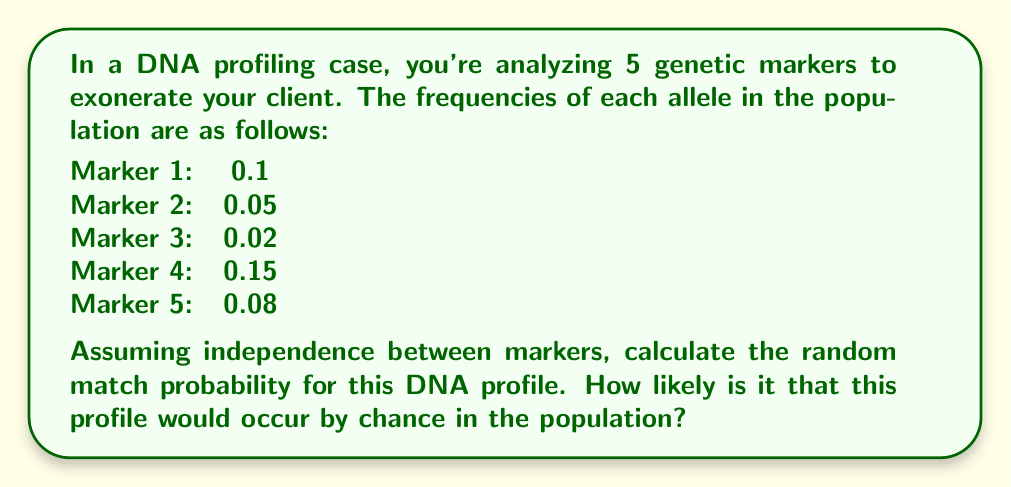Show me your answer to this math problem. To calculate the random match probability for a DNA profile using the product rule, we multiply the frequencies of each individual marker. This assumes independence between markers.

Step 1: Identify the frequencies for each marker
Marker 1: $f_1 = 0.1$
Marker 2: $f_2 = 0.05$
Marker 3: $f_3 = 0.02$
Marker 4: $f_4 = 0.15$
Marker 5: $f_5 = 0.08$

Step 2: Apply the product rule
The random match probability (RMP) is calculated by multiplying these frequencies:

$$RMP = f_1 \times f_2 \times f_3 \times f_4 \times f_5$$

Step 3: Compute the result
$$RMP = 0.1 \times 0.05 \times 0.02 \times 0.15 \times 0.08$$
$$RMP = 1.2 \times 10^{-6}$$

Step 4: Interpret the result
This means the probability of a random individual in the population having this exact DNA profile is approximately 1 in 833,333 (1 / 1.2 × 10^-6).
Answer: $1.2 \times 10^{-6}$ 